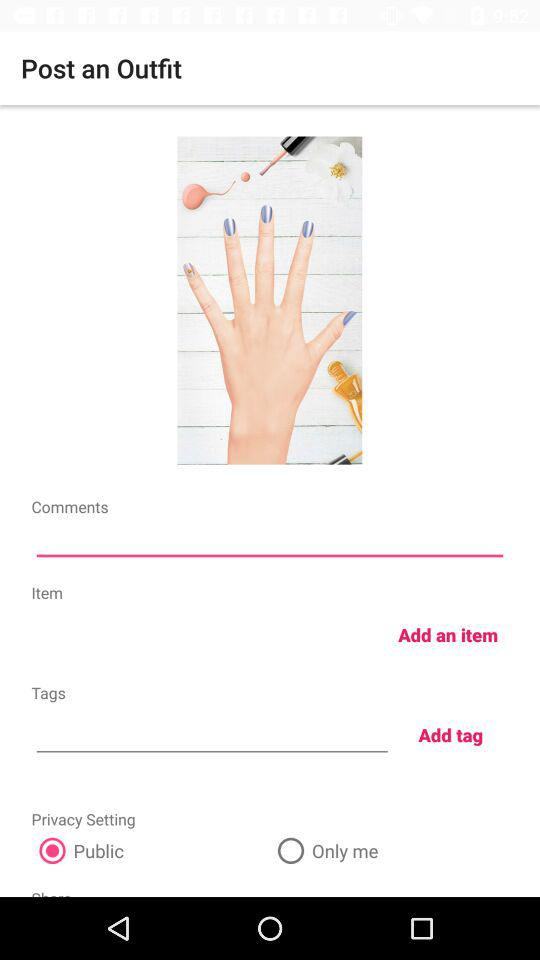Which privacy setting is selected? The selected privacy setting is "Public". 